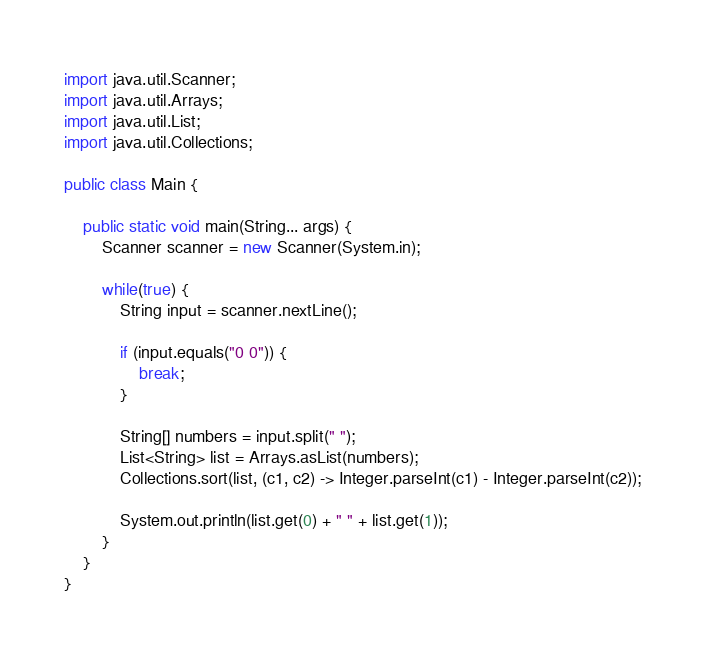<code> <loc_0><loc_0><loc_500><loc_500><_Java_>import java.util.Scanner;
import java.util.Arrays;
import java.util.List;
import java.util.Collections;

public class Main {
    
    public static void main(String... args) {
        Scanner scanner = new Scanner(System.in);
        
        while(true) {
            String input = scanner.nextLine();
            
            if (input.equals("0 0")) {
                break;
            }
            
            String[] numbers = input.split(" ");
            List<String> list = Arrays.asList(numbers);
            Collections.sort(list, (c1, c2) -> Integer.parseInt(c1) - Integer.parseInt(c2));
            
            System.out.println(list.get(0) + " " + list.get(1)); 
        }
    }
}
</code> 